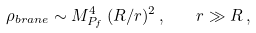<formula> <loc_0><loc_0><loc_500><loc_500>\rho _ { b r a n e } \sim M _ { P _ { f } } ^ { 4 } \, ( R / r ) ^ { 2 } \, , \quad r \gg R \, ,</formula> 